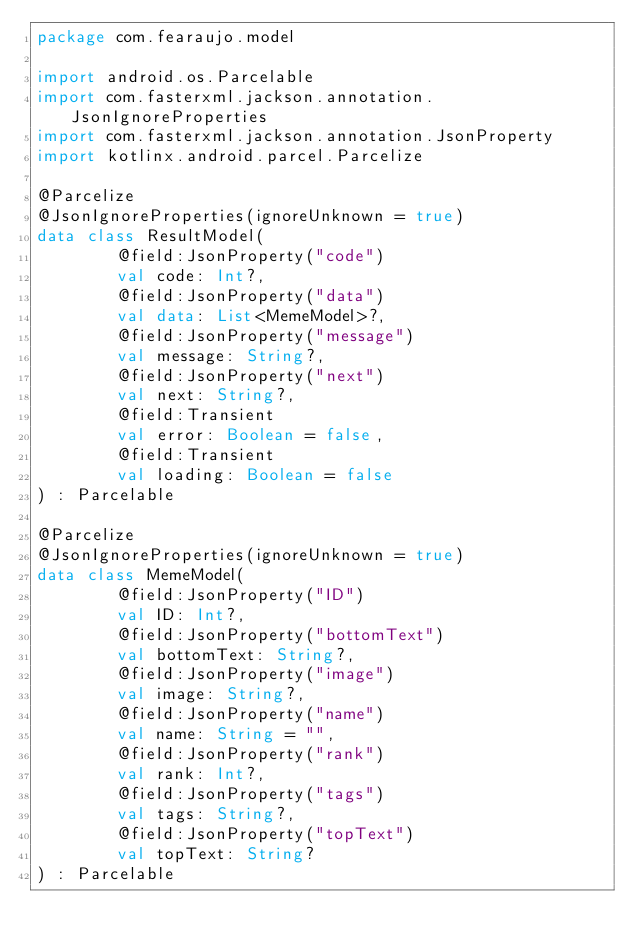<code> <loc_0><loc_0><loc_500><loc_500><_Kotlin_>package com.fearaujo.model

import android.os.Parcelable
import com.fasterxml.jackson.annotation.JsonIgnoreProperties
import com.fasterxml.jackson.annotation.JsonProperty
import kotlinx.android.parcel.Parcelize

@Parcelize
@JsonIgnoreProperties(ignoreUnknown = true)
data class ResultModel(
        @field:JsonProperty("code")
        val code: Int?,
        @field:JsonProperty("data")
        val data: List<MemeModel>?,
        @field:JsonProperty("message")
        val message: String?,
        @field:JsonProperty("next")
        val next: String?,
        @field:Transient
        val error: Boolean = false,
        @field:Transient
        val loading: Boolean = false
) : Parcelable

@Parcelize
@JsonIgnoreProperties(ignoreUnknown = true)
data class MemeModel(
        @field:JsonProperty("ID")
        val ID: Int?,
        @field:JsonProperty("bottomText")
        val bottomText: String?,
        @field:JsonProperty("image")
        val image: String?,
        @field:JsonProperty("name")
        val name: String = "",
        @field:JsonProperty("rank")
        val rank: Int?,
        @field:JsonProperty("tags")
        val tags: String?,
        @field:JsonProperty("topText")
        val topText: String?
) : Parcelable
</code> 